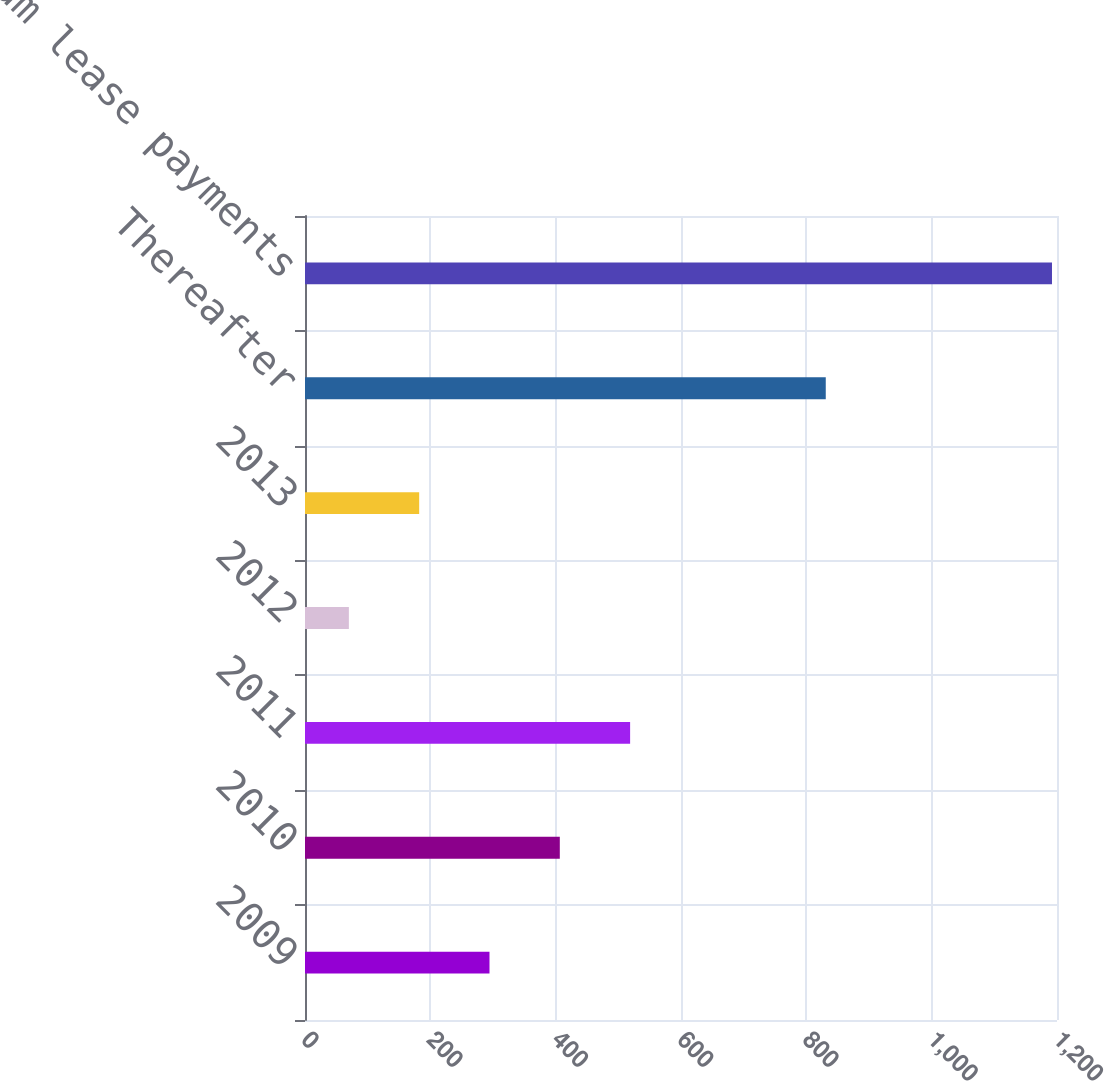<chart> <loc_0><loc_0><loc_500><loc_500><bar_chart><fcel>2009<fcel>2010<fcel>2011<fcel>2012<fcel>2013<fcel>Thereafter<fcel>Total minimum lease payments<nl><fcel>294.4<fcel>406.6<fcel>518.8<fcel>70<fcel>182.2<fcel>831<fcel>1192<nl></chart> 